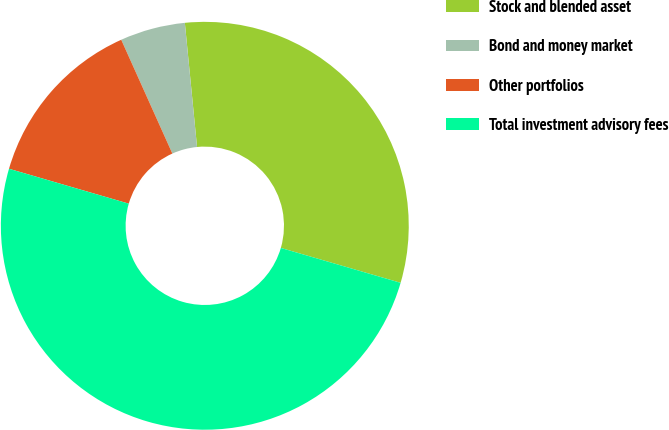Convert chart to OTSL. <chart><loc_0><loc_0><loc_500><loc_500><pie_chart><fcel>Stock and blended asset<fcel>Bond and money market<fcel>Other portfolios<fcel>Total investment advisory fees<nl><fcel>31.07%<fcel>5.16%<fcel>13.77%<fcel>50.0%<nl></chart> 